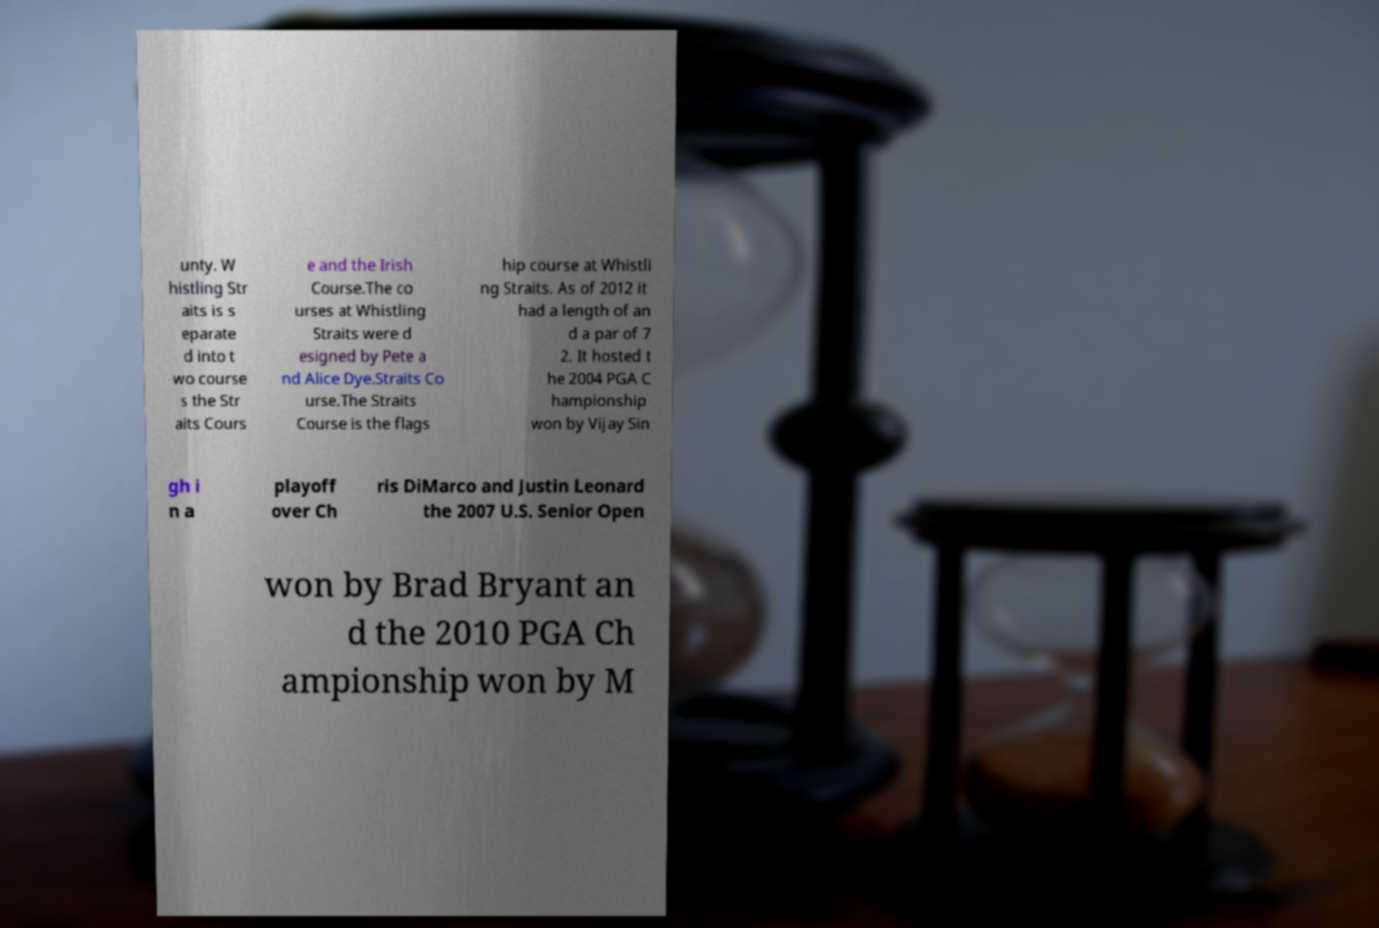I need the written content from this picture converted into text. Can you do that? unty. W histling Str aits is s eparate d into t wo course s the Str aits Cours e and the Irish Course.The co urses at Whistling Straits were d esigned by Pete a nd Alice Dye.Straits Co urse.The Straits Course is the flags hip course at Whistli ng Straits. As of 2012 it had a length of an d a par of 7 2. It hosted t he 2004 PGA C hampionship won by Vijay Sin gh i n a playoff over Ch ris DiMarco and Justin Leonard the 2007 U.S. Senior Open won by Brad Bryant an d the 2010 PGA Ch ampionship won by M 